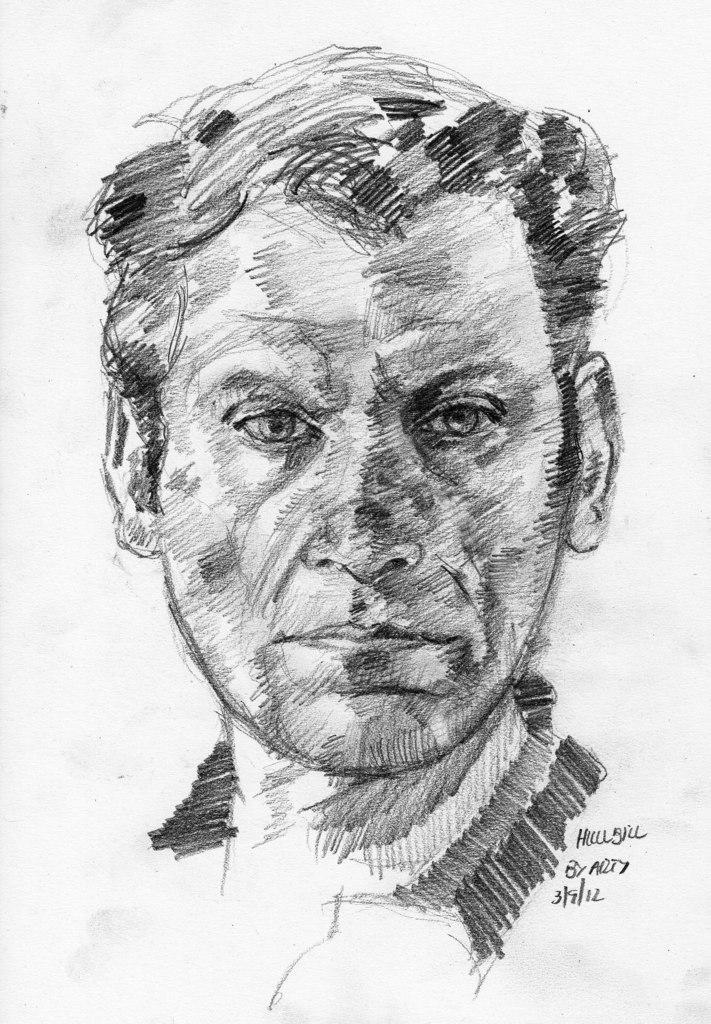Describe this image in one or two sentences. In this picture we can see a drawing of a man and some text. 